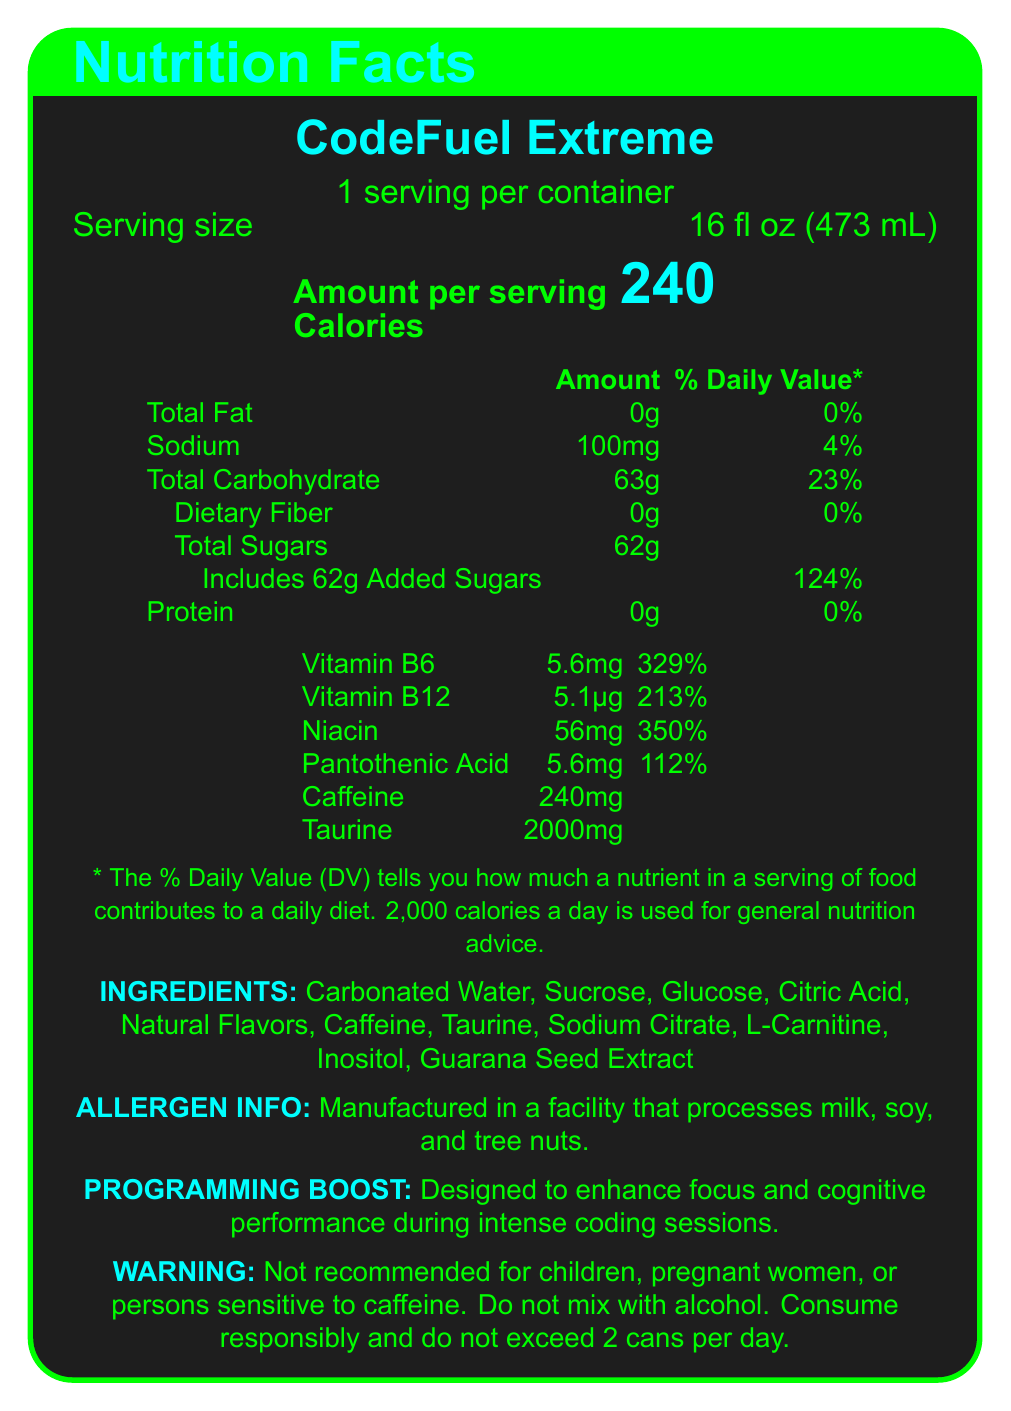What is the serving size of CodeFuel Extreme? The serving size is specified as 16 fl oz (473 mL) in the document.
Answer: 16 fl oz (473 mL) How many calories are in a serving of CodeFuel Extreme? The document states that there are 240 calories per serving.
Answer: 240 What is the daily value percentage of sodium in CodeFuel Extreme? The table lists the sodium content as 100mg, which is 4% of the daily value.
Answer: 4% How much caffeine does one serving of CodeFuel Extreme contain? Under the vitamins and minerals section, it lists 240mg of caffeine.
Answer: 240mg What claim does CodeFuel Extreme make about its effects during coding sessions? The document has a section titled "PROGRAMMING BOOST" that specifies this claim.
Answer: Designed to enhance focus and cognitive performance during intense coding sessions. Which of the following vitamins has the highest daily value percentage in CodeFuel Extreme?
A. Vitamin B6
B. Vitamin B12
C. Niacin
D. Pantothenic Acid Niacin is listed with 350% daily value, which is the highest among the vitamins and minerals listed.
Answer: C What percentage of the daily value of added sugars is included in CodeFuel Extreme? 
A. 62%
B. 124%
C. 233% The document lists 62g of added sugars, which equals 124% of the daily value.
Answer: B True or False: CodeFuel Extreme contains dietary fiber. The document states that there is 0g of dietary fiber in the product.
Answer: False What is the total carbohydrate content per serving in CodeFuel Extreme? The document lists the total carbohydrate content as 63g.
Answer: 63g Does CodeFuel Extreme contain any protein? The document states that the protein content is 0g.
Answer: No What are the primary ingredients in CodeFuel Extreme? The ingredients are listed clearly in an "INGREDIENTS" section.
Answer: Carbonated Water, Sucrose, Glucose, Citric Acid, Natural Flavors, Caffeine, Taurine, Sodium Citrate, L-Carnitine, Inositol, Guarana Seed Extract Summarize the main idea of the document. The document is focused on providing nutritional details and important usage information for consumers.
Answer: The document is a Nutrition Facts label for CodeFuel Extreme, detailing its serving size, nutritional content (like calories, fats, sugars, vitamins, and minerals), ingredients, allergen information, a claim about enhancing cognitive performance during coding sessions, and a warning about its consumption. Who manufactures CodeFuel Extreme? The document does not provide any information about the manufacturer of CodeFuel Extreme.
Answer: Not enough information 